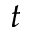<formula> <loc_0><loc_0><loc_500><loc_500>t</formula> 